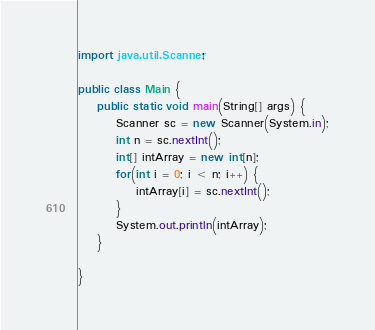Convert code to text. <code><loc_0><loc_0><loc_500><loc_500><_Java_>import java.util.Scanner;

public class Main {
	public static void main(String[] args) {
		Scanner sc = new Scanner(System.in);
		int n = sc.nextInt();
		int[] intArray = new int[n];
		for(int i = 0; i < n; i++) {
			intArray[i] = sc.nextInt();
		}
		System.out.println(intArray);
	}

}</code> 